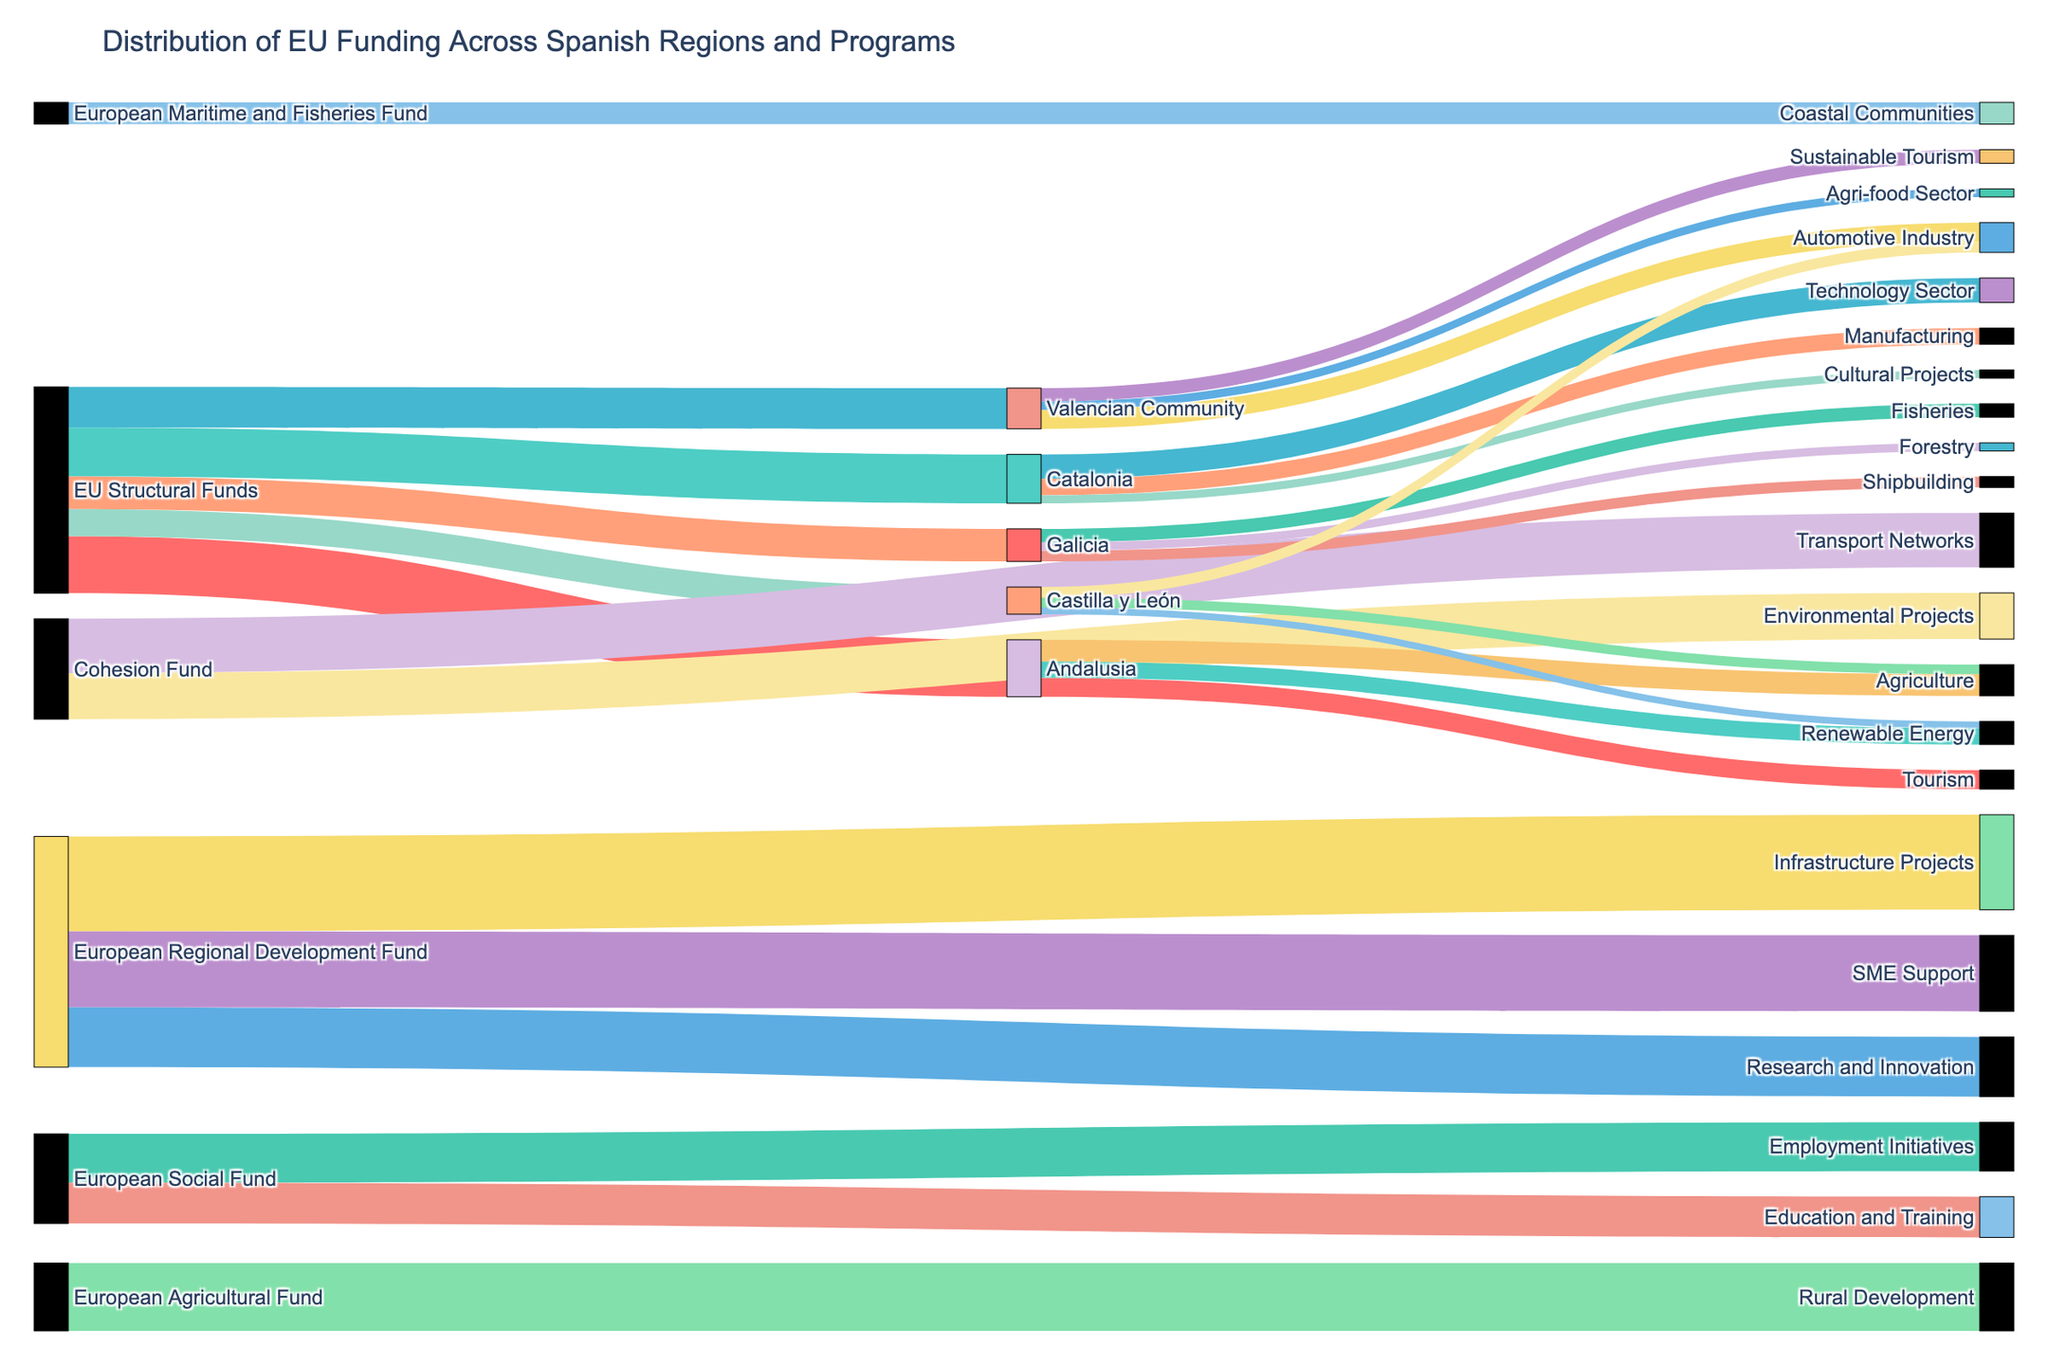Which region received the highest EU Structural Funds? Andalusia received 2100, Catalonia received 1800, Valencian Community received 1500, Galicia received 1200, and Castilla y León received 1000 from the EU Structural Funds. Thus, the highest value goes to Andalusia.
Answer: Andalusia What is the total amount of funding received from the European Regional Development Fund? Sum the values: Infrastructure Projects (3500) + SME Support (2800) + Research and Innovation (2200). Hence, total funding is 3500 + 2800 + 2200.
Answer: 8500 Which economic program received less funding from the EU: Environmental Projects or Rural Development? Environmental Projects received 1700, while Rural Development received 2500. Comparing these values shows that Environmental Projects received less.
Answer: Environmental Projects What is the combined funding amount for Employment Initiatives and Education and Training? Employment Initiatives received 1800 and Education and Training received 1500. The combined funding is 1800 + 1500.
Answer: 3300 Which sector received the most funding in Andalusia? In Andalusia, Agriculture received 800, Tourism 700, and Renewable Energy 600. The sector with the highest value is Agriculture.
Answer: Agriculture How does the funding for Technology Sector in Catalonia compare to the funding for Fisheries in Galicia? Technology Sector in Catalonia received 900, while Fisheries in Galicia received 500. Comparing both, Technology Sector in Catalonia received more funding.
Answer: Technology Sector Between the Valencian Community and Castilla y León, which region received more total funding? Valencian Community: 1500. Castilla y León: 1000. Valencian Community got more.
Answer: Valencian Community What's the total value for funding directed towards transport and environmental projects from the Cohesion Fund? Transport Networks received 2000 and Environmental Projects received 1700. Summing these gives 2000 + 1700.
Answer: 3700 Which region has the smallest amount of EU Structural Funds? Comparing values: Andalusia (2100), Catalonia (1800), Valencian Community (1500), Galicia (1200), and Castilla y León (1000). Castilla y León has the smallest amount.
Answer: Castilla y León Is the funding for Infrastructure Projects higher than the combined total for SME Support and Research and Innovation? Infrastructure Projects received 3500, SME Support (2800) + Research and Innovation (2200) = 5000. Thus, Infrastructure Projects funding is lower than this combined total.
Answer: No 